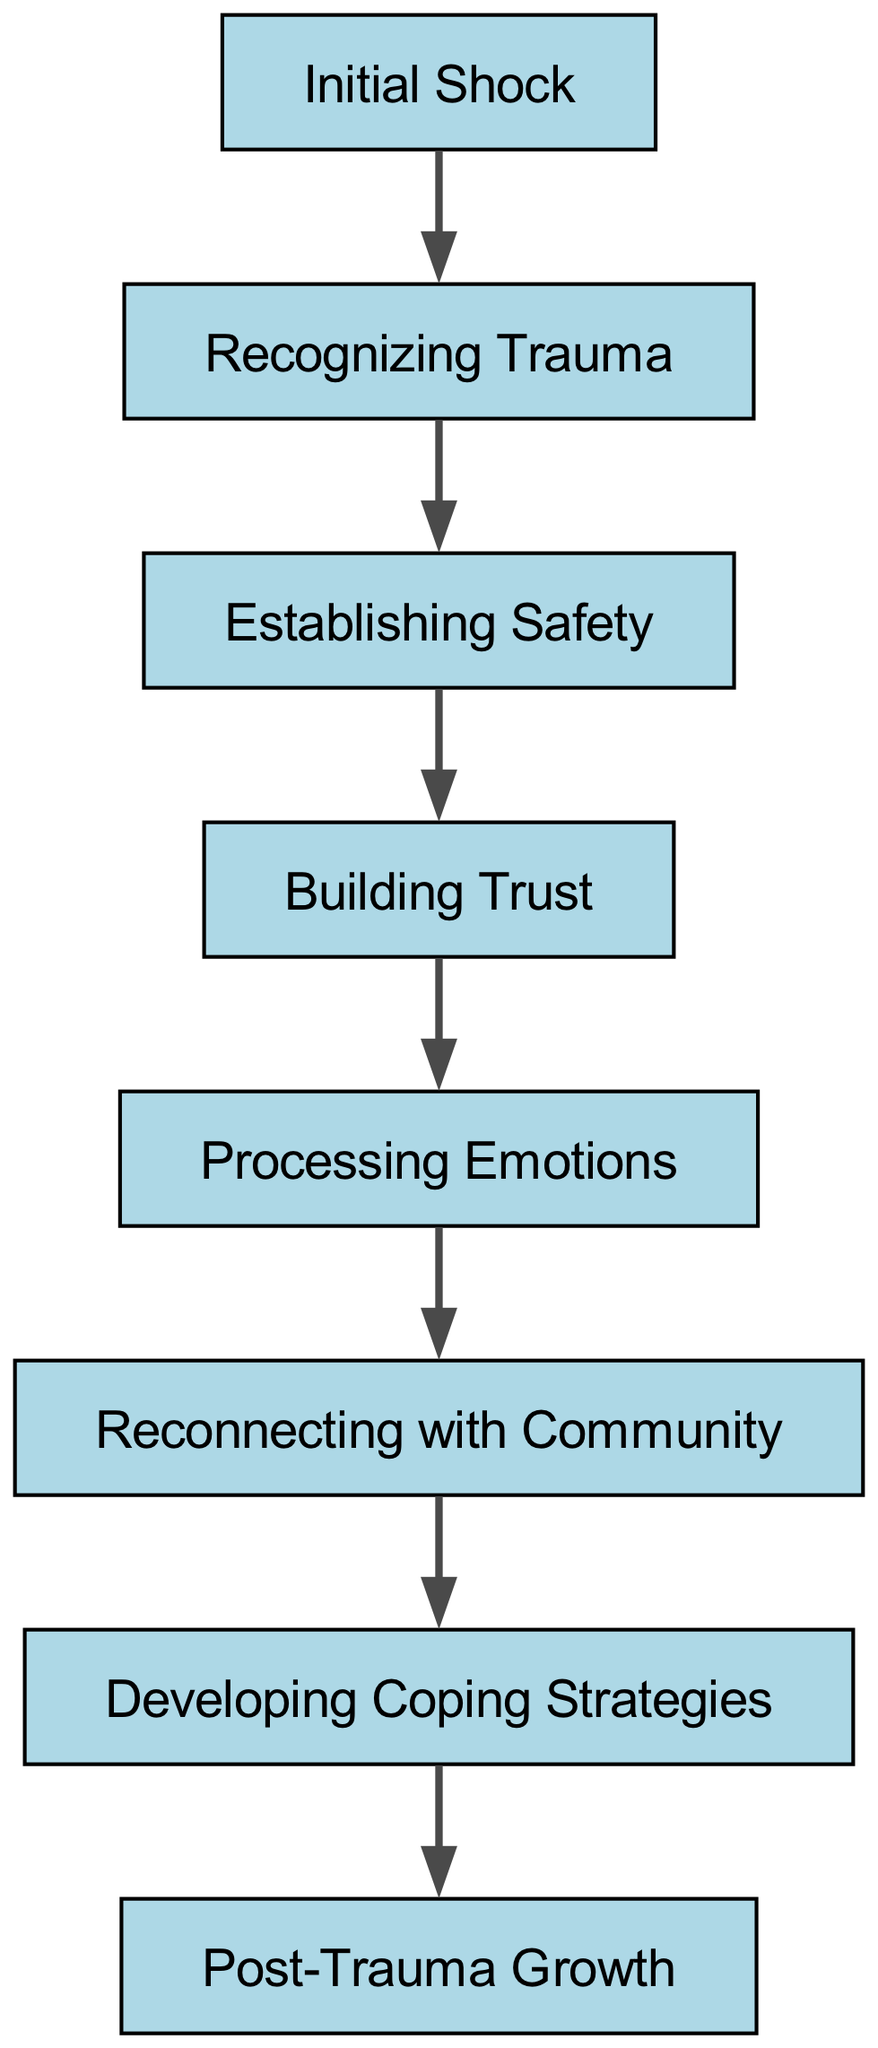What is the first stage of trauma recovery? The diagram shows "Initial Shock" as the first node, indicating it is the starting point of trauma recovery.
Answer: Initial Shock How many nodes are there in total? Counting all the listed nodes in the diagram, we find there are eight distinct stages of trauma recovery.
Answer: 8 What stage comes after "Recognizing Trauma"? In the directed graph, the edge from node "2" to node "3" indicates that "Establishing Safety" is the next stage following "Recognizing Trauma".
Answer: Establishing Safety What is the final stage of recovery? The last node in the diagram is "Post-Trauma Growth", which signifies the completion of the recovery process.
Answer: Post-Trauma Growth Which stage precedes "Building Trust"? The arrow connecting "3" to "4" indicates that "Establishing Safety" is the stage that comes before "Building Trust".
Answer: Establishing Safety How does "Processing Emotions" relate to "Reconnecting with Community"? The directed edge from "5" to "6" shows a direct relationship between "Processing Emotions" and "Reconnecting with Community", indicating that one stage leads directly to the other.
Answer: Processing Emotions What is the only stage that leads directly to "Post-Trauma Growth"? According to the diagram, "Developing Coping Strategies" is the only stage with a direct link to "Post-Trauma Growth", indicating it is the preceding stage in the recovery process.
Answer: Developing Coping Strategies How many edges are there in the graph? By counting the directed connections between the nodes, we see that there are seven edges representing the transitions between the stages.
Answer: 7 Which two stages are directly connected with an edge? The edge indicates that "Initial Shock" (node 1) is directly connected to "Recognizing Trauma" (node 2), showing a clear relationship between these two stages.
Answer: Initial Shock and Recognizing Trauma 